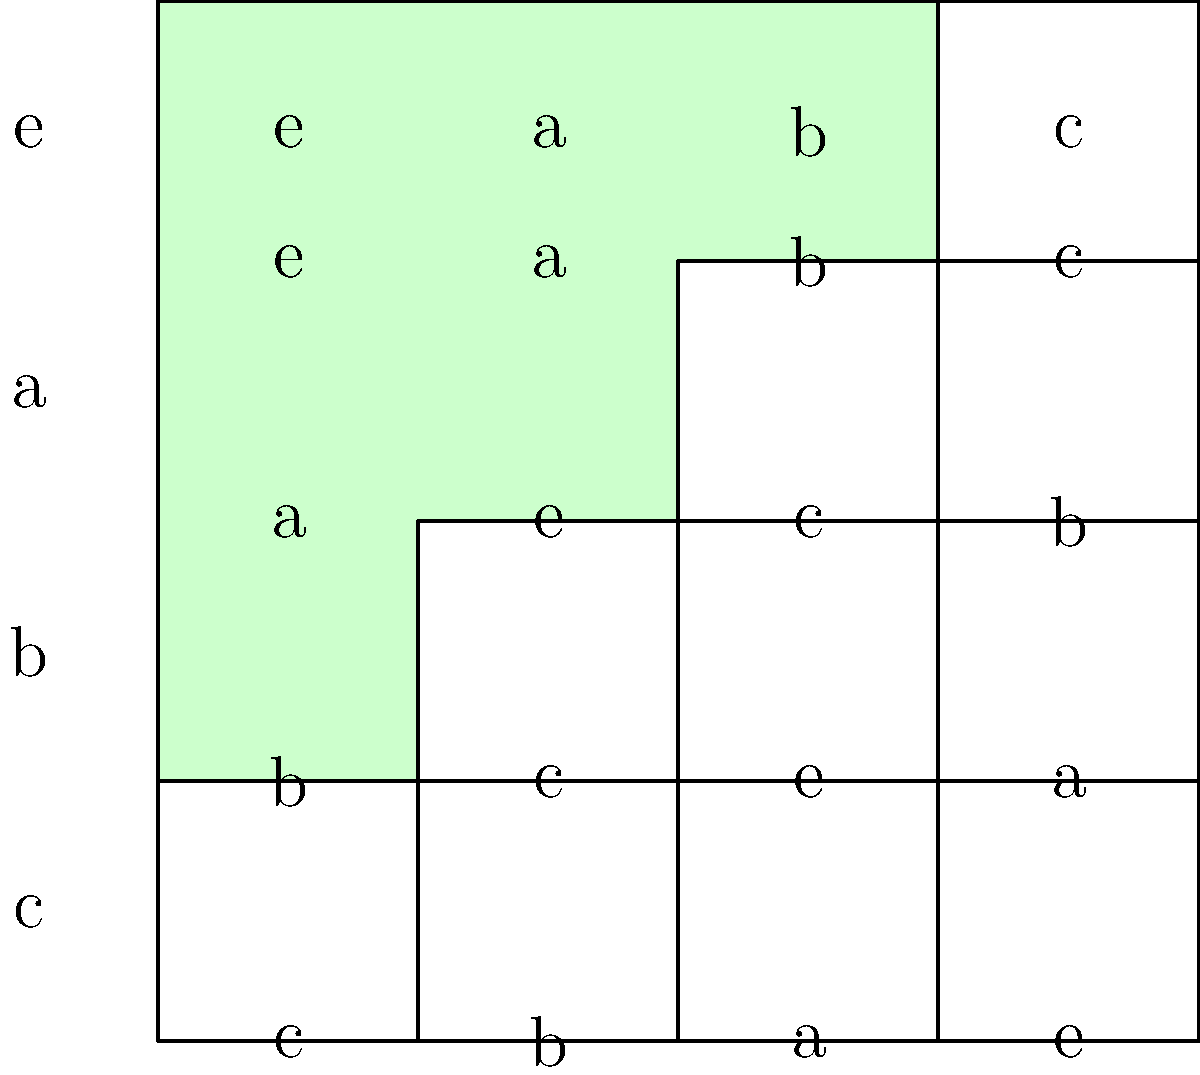In the Cayley table of a group $G = \{e,a,b,c\}$ shown above, two subgroups are highlighted: $H_1 = \{e,a\}$ in pink and $H_2 = \{e,b\}$ in green. If we consider the subgroup $K = \langle c \rangle$ generated by the element $c$, what is the order of $K$, and how would it be visualized in the Cayley table? To solve this problem, let's follow these steps:

1) First, we need to understand what $\langle c \rangle$ means. It's the subgroup generated by $c$, which includes all powers of $c$.

2) To find the powers of $c$, we start with $c$ and keep multiplying by $c$ until we get back to the identity element $e$:

   $c^1 = c$
   $c^2 = c \cdot c = b$ (from the table)
   $c^3 = c \cdot b = a$ (from the table)
   $c^4 = c \cdot a = e$ (from the table)

3) We see that $c^4 = e$, which means the cycle closes after 4 steps.

4) Therefore, $K = \langle c \rangle = \{e,c,b,a\}$, which is actually the entire group $G$.

5) The order of $K$ is thus 4.

6) To visualize $K$ in the Cayley table, we would need to highlight the entire table, as $K = G$.

This result is particularly interesting in the context of Zimbabwe and Gift Tarupiwa's work on group theory applications in cryptography, as it shows how a single element can generate the entire group, a property often used in cryptographic protocols.
Answer: Order of $K$ is 4; visualized as the entire Cayley table. 